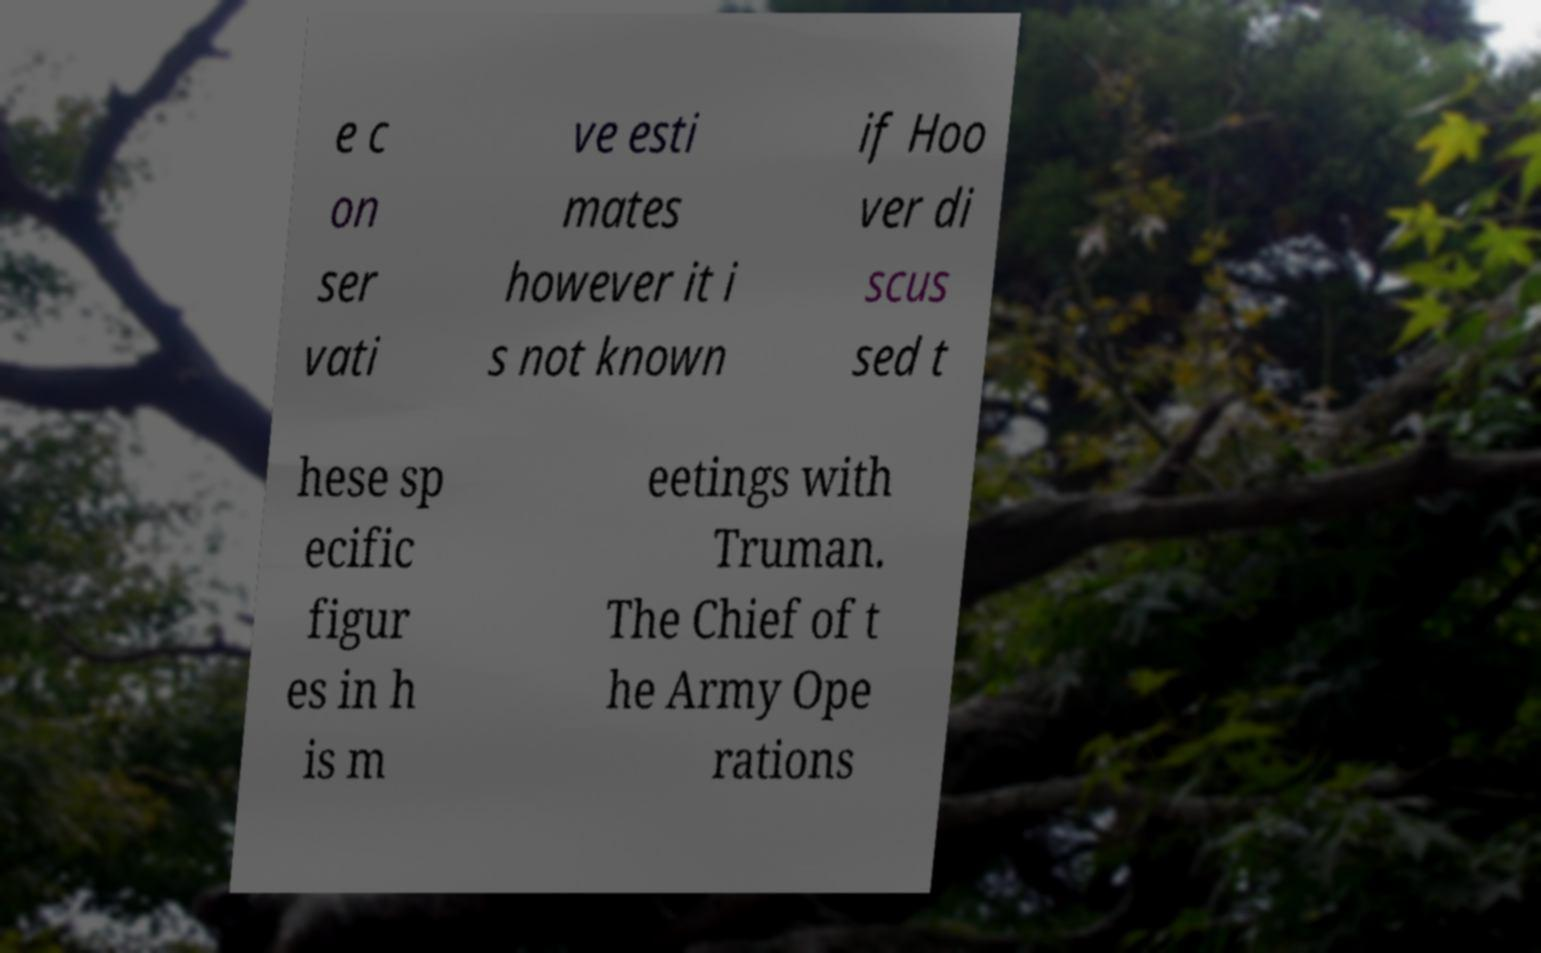Could you extract and type out the text from this image? e c on ser vati ve esti mates however it i s not known if Hoo ver di scus sed t hese sp ecific figur es in h is m eetings with Truman. The Chief of t he Army Ope rations 